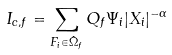Convert formula to latex. <formula><loc_0><loc_0><loc_500><loc_500>I _ { c , f } = \sum _ { F _ { i } \in \hat { \Omega } _ { f } } Q _ { f } \Psi _ { i } | X _ { i } | ^ { - \alpha }</formula> 